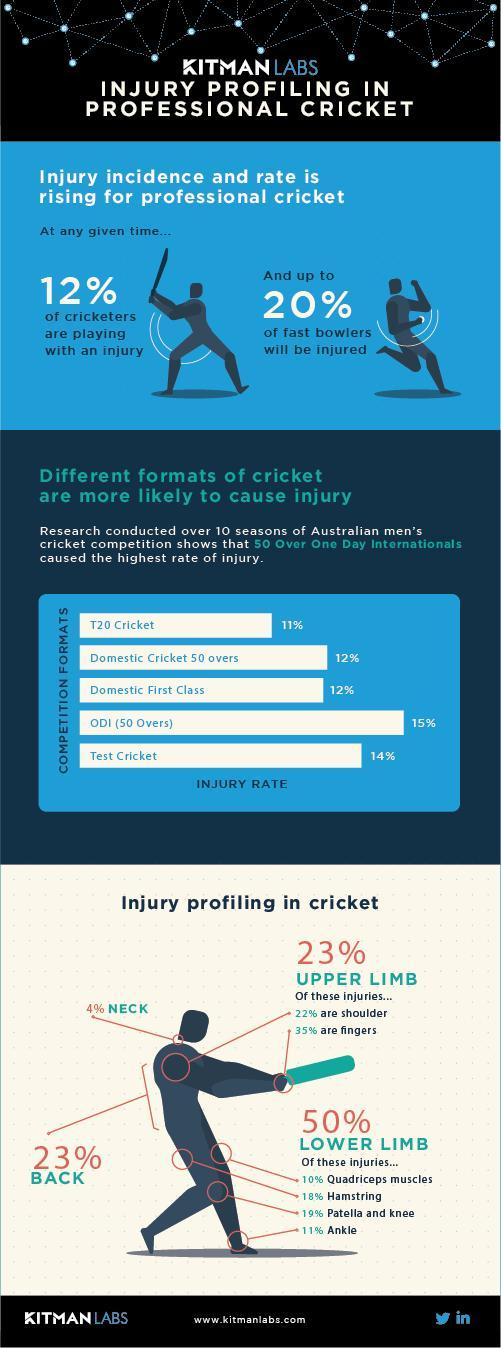Which part of the body is more prone to injuries ?
Answer the question with a short phrase. Lower Limb What was the rate of injury in domestic cricket and domestic first class? 12% 